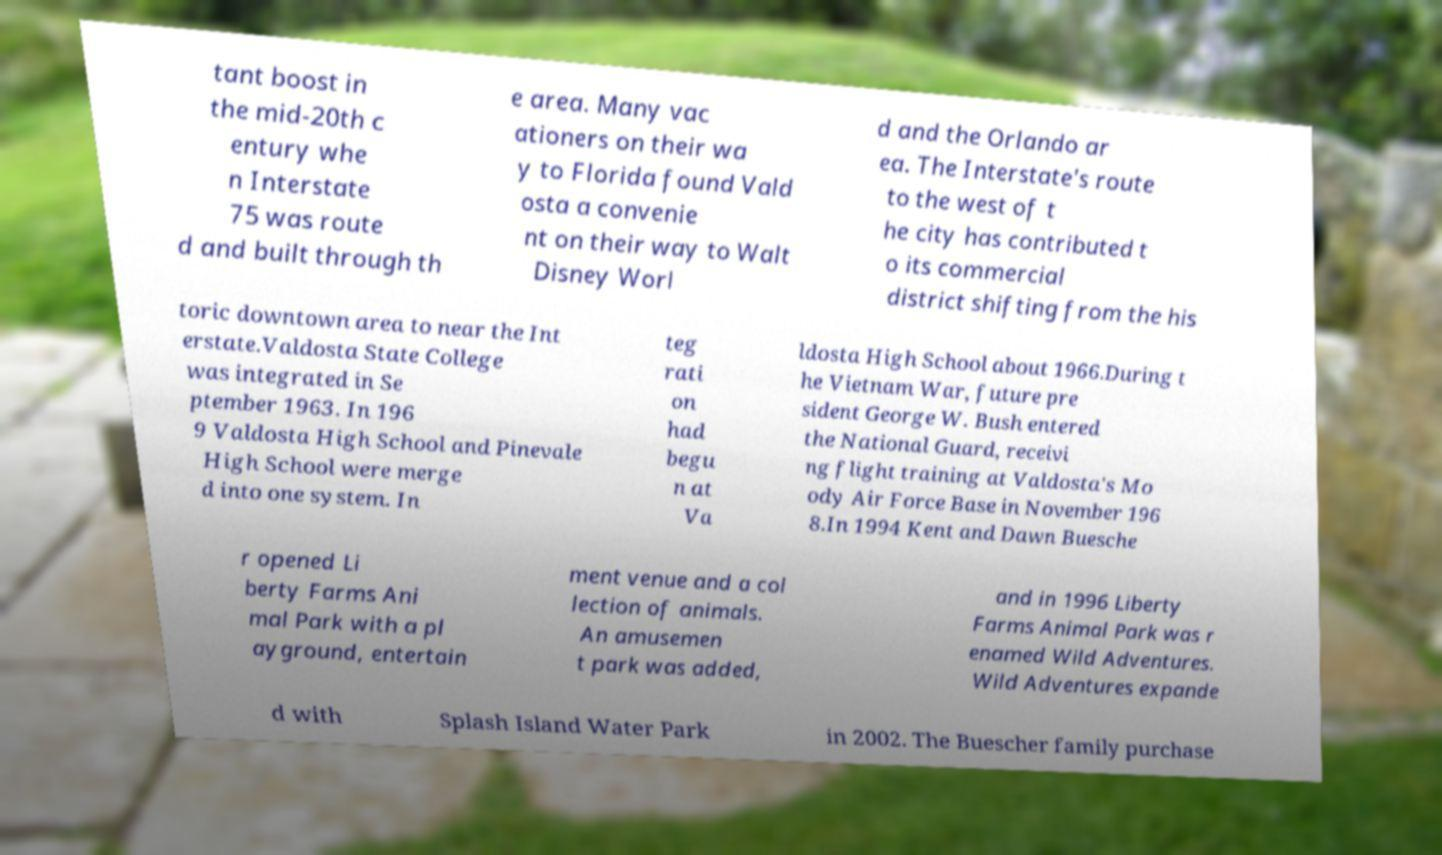For documentation purposes, I need the text within this image transcribed. Could you provide that? tant boost in the mid-20th c entury whe n Interstate 75 was route d and built through th e area. Many vac ationers on their wa y to Florida found Vald osta a convenie nt on their way to Walt Disney Worl d and the Orlando ar ea. The Interstate's route to the west of t he city has contributed t o its commercial district shifting from the his toric downtown area to near the Int erstate.Valdosta State College was integrated in Se ptember 1963. In 196 9 Valdosta High School and Pinevale High School were merge d into one system. In teg rati on had begu n at Va ldosta High School about 1966.During t he Vietnam War, future pre sident George W. Bush entered the National Guard, receivi ng flight training at Valdosta's Mo ody Air Force Base in November 196 8.In 1994 Kent and Dawn Buesche r opened Li berty Farms Ani mal Park with a pl ayground, entertain ment venue and a col lection of animals. An amusemen t park was added, and in 1996 Liberty Farms Animal Park was r enamed Wild Adventures. Wild Adventures expande d with Splash Island Water Park in 2002. The Buescher family purchase 